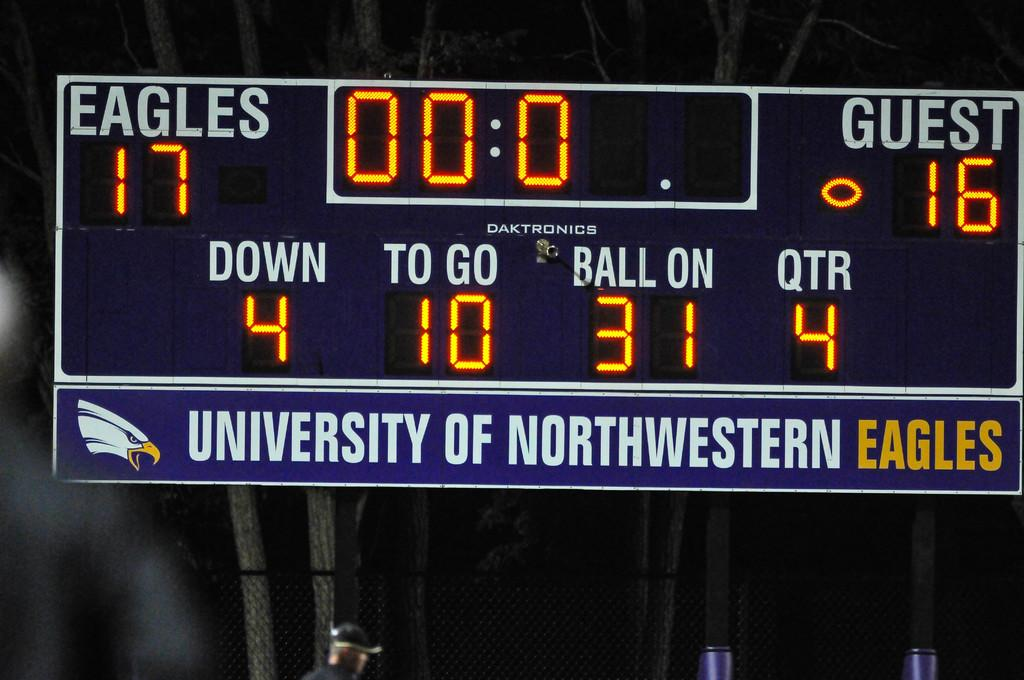<image>
Offer a succinct explanation of the picture presented. scoreboard for university of northwestern eagles showing the eagles up by 1 with no time left 